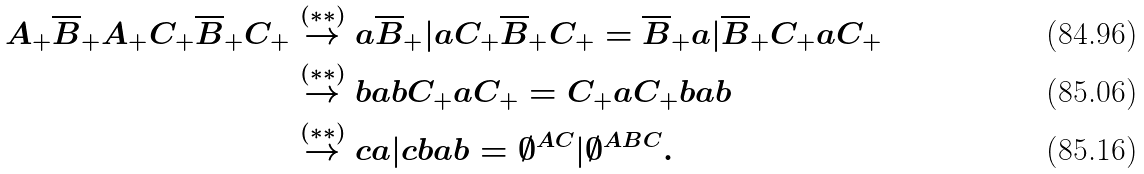Convert formula to latex. <formula><loc_0><loc_0><loc_500><loc_500>A _ { + } \overline { B } _ { + } A _ { + } C _ { + } \overline { B } _ { + } C _ { + } & \stackrel { ( \ast \ast ) } { \rightarrow } a \overline { B } _ { + } | a C _ { + } \overline { B } _ { + } C _ { + } = \overline { B } _ { + } a | \overline { B } _ { + } C _ { + } a C _ { + } \\ & \stackrel { ( \ast \ast ) } { \rightarrow } b a b C _ { + } a C _ { + } = C _ { + } a C _ { + } b a b \\ & \stackrel { ( \ast \ast ) } { \rightarrow } c a | c b a b = { \emptyset } ^ { A C } | { \emptyset } ^ { A B C } .</formula> 